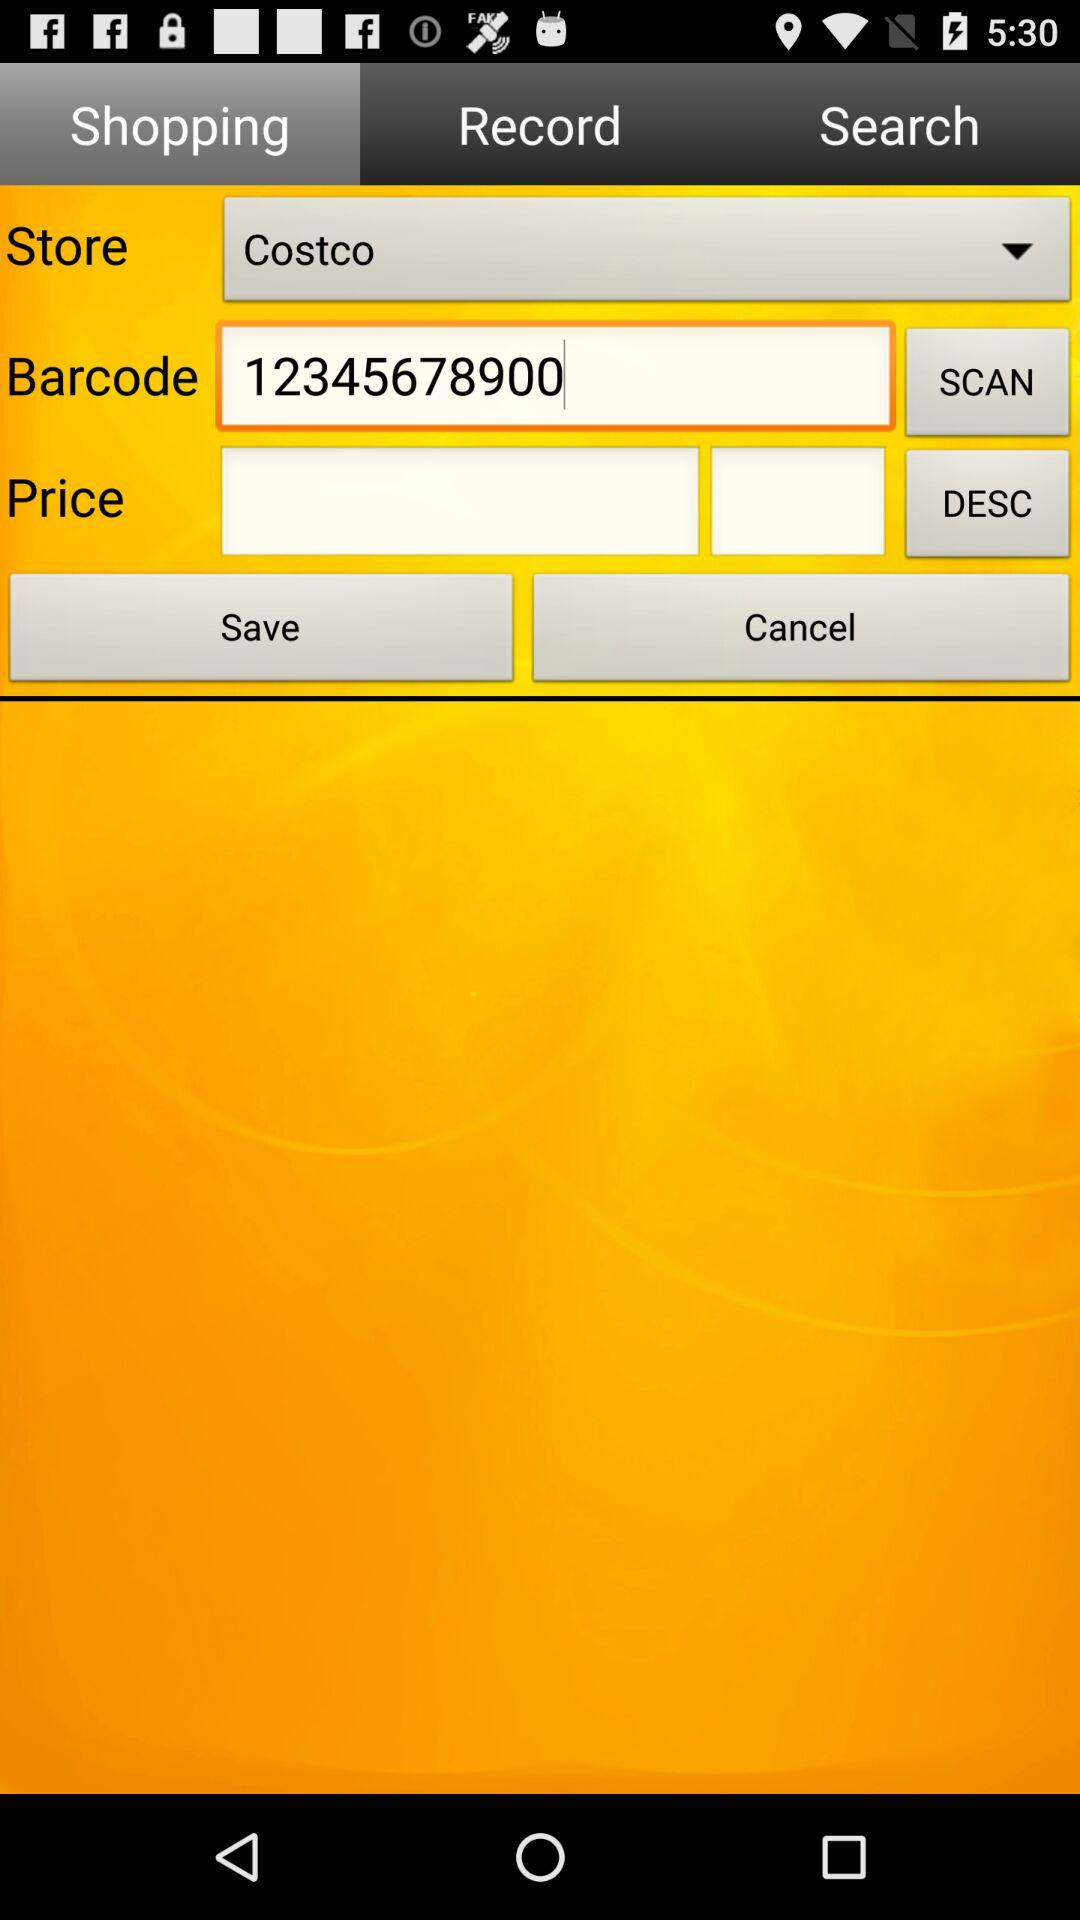What is the store name? The store name is "Costco". 